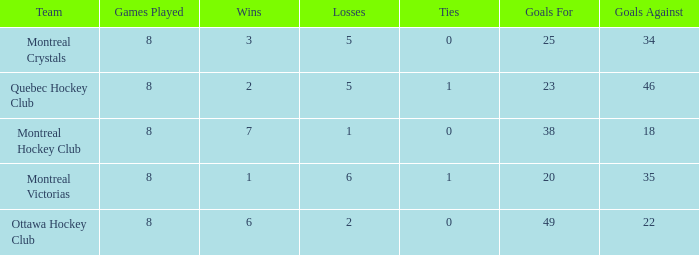What is the highest goals against when the wins is less than 1? None. 